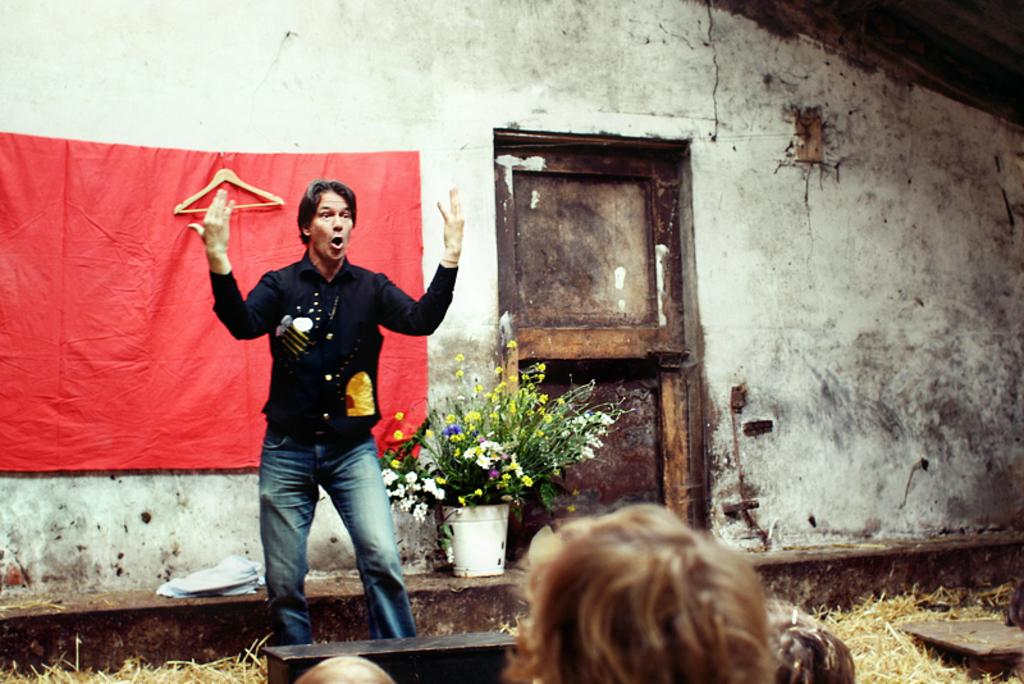What is the person in the image doing? There is a person talking in the image. What can be seen behind the person? There is a wall behind the person. What item is present in the image that can be used for hanging clothes? There is a hanger in the image. What type of plant is visible in the image? There is a houseplant in the image. What objects are made of wood and located at the bottom of the image? There are wooden objects at the bottom of the image. What verse is the person reciting in the image? There is no indication in the image that the person is reciting a verse. How does the mark on the wall move in the image? There is no mark on the wall in the image. Can you describe the person's ability to jump in the image? There is no information about the person's ability to jump in the image. 